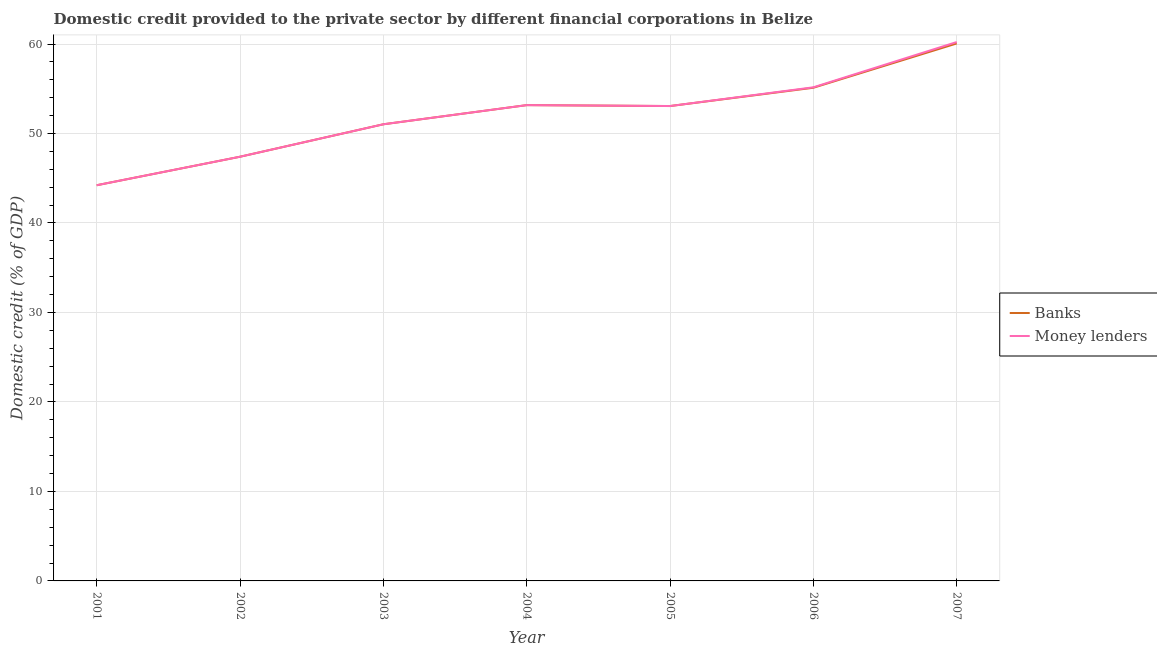How many different coloured lines are there?
Offer a terse response. 2. Does the line corresponding to domestic credit provided by banks intersect with the line corresponding to domestic credit provided by money lenders?
Your answer should be compact. Yes. Is the number of lines equal to the number of legend labels?
Provide a succinct answer. Yes. What is the domestic credit provided by banks in 2001?
Offer a very short reply. 44.22. Across all years, what is the maximum domestic credit provided by banks?
Your answer should be compact. 60.06. Across all years, what is the minimum domestic credit provided by banks?
Make the answer very short. 44.22. In which year was the domestic credit provided by banks maximum?
Keep it short and to the point. 2007. What is the total domestic credit provided by banks in the graph?
Your answer should be very brief. 364.07. What is the difference between the domestic credit provided by money lenders in 2002 and that in 2004?
Provide a succinct answer. -5.77. What is the difference between the domestic credit provided by banks in 2004 and the domestic credit provided by money lenders in 2007?
Provide a succinct answer. -7.05. What is the average domestic credit provided by banks per year?
Your answer should be very brief. 52.01. What is the ratio of the domestic credit provided by banks in 2001 to that in 2005?
Your answer should be compact. 0.83. What is the difference between the highest and the second highest domestic credit provided by banks?
Your answer should be very brief. 4.95. What is the difference between the highest and the lowest domestic credit provided by money lenders?
Provide a short and direct response. 16. In how many years, is the domestic credit provided by money lenders greater than the average domestic credit provided by money lenders taken over all years?
Offer a terse response. 4. Is the domestic credit provided by money lenders strictly less than the domestic credit provided by banks over the years?
Your answer should be very brief. No. How many years are there in the graph?
Your answer should be compact. 7. Are the values on the major ticks of Y-axis written in scientific E-notation?
Offer a terse response. No. Where does the legend appear in the graph?
Give a very brief answer. Center right. How are the legend labels stacked?
Keep it short and to the point. Vertical. What is the title of the graph?
Give a very brief answer. Domestic credit provided to the private sector by different financial corporations in Belize. What is the label or title of the Y-axis?
Your answer should be compact. Domestic credit (% of GDP). What is the Domestic credit (% of GDP) in Banks in 2001?
Keep it short and to the point. 44.22. What is the Domestic credit (% of GDP) of Money lenders in 2001?
Your answer should be very brief. 44.22. What is the Domestic credit (% of GDP) of Banks in 2002?
Offer a terse response. 47.4. What is the Domestic credit (% of GDP) of Money lenders in 2002?
Provide a succinct answer. 47.4. What is the Domestic credit (% of GDP) in Banks in 2003?
Offer a very short reply. 51.03. What is the Domestic credit (% of GDP) in Money lenders in 2003?
Your response must be concise. 51.03. What is the Domestic credit (% of GDP) of Banks in 2004?
Offer a very short reply. 53.17. What is the Domestic credit (% of GDP) of Money lenders in 2004?
Your answer should be compact. 53.17. What is the Domestic credit (% of GDP) in Banks in 2005?
Make the answer very short. 53.07. What is the Domestic credit (% of GDP) in Money lenders in 2005?
Give a very brief answer. 53.07. What is the Domestic credit (% of GDP) of Banks in 2006?
Offer a terse response. 55.11. What is the Domestic credit (% of GDP) of Money lenders in 2006?
Provide a short and direct response. 55.16. What is the Domestic credit (% of GDP) of Banks in 2007?
Your answer should be compact. 60.06. What is the Domestic credit (% of GDP) in Money lenders in 2007?
Offer a terse response. 60.22. Across all years, what is the maximum Domestic credit (% of GDP) in Banks?
Provide a succinct answer. 60.06. Across all years, what is the maximum Domestic credit (% of GDP) in Money lenders?
Offer a terse response. 60.22. Across all years, what is the minimum Domestic credit (% of GDP) of Banks?
Ensure brevity in your answer.  44.22. Across all years, what is the minimum Domestic credit (% of GDP) of Money lenders?
Keep it short and to the point. 44.22. What is the total Domestic credit (% of GDP) of Banks in the graph?
Offer a terse response. 364.07. What is the total Domestic credit (% of GDP) in Money lenders in the graph?
Your answer should be compact. 364.27. What is the difference between the Domestic credit (% of GDP) of Banks in 2001 and that in 2002?
Offer a terse response. -3.19. What is the difference between the Domestic credit (% of GDP) of Money lenders in 2001 and that in 2002?
Your answer should be compact. -3.19. What is the difference between the Domestic credit (% of GDP) of Banks in 2001 and that in 2003?
Offer a terse response. -6.81. What is the difference between the Domestic credit (% of GDP) in Money lenders in 2001 and that in 2003?
Your answer should be compact. -6.81. What is the difference between the Domestic credit (% of GDP) in Banks in 2001 and that in 2004?
Your answer should be compact. -8.95. What is the difference between the Domestic credit (% of GDP) in Money lenders in 2001 and that in 2004?
Your response must be concise. -8.95. What is the difference between the Domestic credit (% of GDP) of Banks in 2001 and that in 2005?
Offer a terse response. -8.85. What is the difference between the Domestic credit (% of GDP) in Money lenders in 2001 and that in 2005?
Ensure brevity in your answer.  -8.85. What is the difference between the Domestic credit (% of GDP) of Banks in 2001 and that in 2006?
Provide a short and direct response. -10.9. What is the difference between the Domestic credit (% of GDP) in Money lenders in 2001 and that in 2006?
Provide a short and direct response. -10.94. What is the difference between the Domestic credit (% of GDP) of Banks in 2001 and that in 2007?
Provide a succinct answer. -15.85. What is the difference between the Domestic credit (% of GDP) of Money lenders in 2001 and that in 2007?
Offer a very short reply. -16. What is the difference between the Domestic credit (% of GDP) of Banks in 2002 and that in 2003?
Provide a short and direct response. -3.63. What is the difference between the Domestic credit (% of GDP) in Money lenders in 2002 and that in 2003?
Provide a short and direct response. -3.63. What is the difference between the Domestic credit (% of GDP) in Banks in 2002 and that in 2004?
Your response must be concise. -5.77. What is the difference between the Domestic credit (% of GDP) in Money lenders in 2002 and that in 2004?
Your answer should be compact. -5.77. What is the difference between the Domestic credit (% of GDP) of Banks in 2002 and that in 2005?
Offer a terse response. -5.66. What is the difference between the Domestic credit (% of GDP) of Money lenders in 2002 and that in 2005?
Provide a short and direct response. -5.66. What is the difference between the Domestic credit (% of GDP) in Banks in 2002 and that in 2006?
Your answer should be compact. -7.71. What is the difference between the Domestic credit (% of GDP) of Money lenders in 2002 and that in 2006?
Make the answer very short. -7.76. What is the difference between the Domestic credit (% of GDP) of Banks in 2002 and that in 2007?
Your response must be concise. -12.66. What is the difference between the Domestic credit (% of GDP) in Money lenders in 2002 and that in 2007?
Your answer should be very brief. -12.82. What is the difference between the Domestic credit (% of GDP) of Banks in 2003 and that in 2004?
Provide a short and direct response. -2.14. What is the difference between the Domestic credit (% of GDP) of Money lenders in 2003 and that in 2004?
Provide a succinct answer. -2.14. What is the difference between the Domestic credit (% of GDP) of Banks in 2003 and that in 2005?
Provide a short and direct response. -2.04. What is the difference between the Domestic credit (% of GDP) in Money lenders in 2003 and that in 2005?
Your answer should be very brief. -2.04. What is the difference between the Domestic credit (% of GDP) in Banks in 2003 and that in 2006?
Ensure brevity in your answer.  -4.08. What is the difference between the Domestic credit (% of GDP) of Money lenders in 2003 and that in 2006?
Your answer should be compact. -4.13. What is the difference between the Domestic credit (% of GDP) of Banks in 2003 and that in 2007?
Provide a succinct answer. -9.03. What is the difference between the Domestic credit (% of GDP) of Money lenders in 2003 and that in 2007?
Keep it short and to the point. -9.19. What is the difference between the Domestic credit (% of GDP) in Banks in 2004 and that in 2005?
Your answer should be compact. 0.1. What is the difference between the Domestic credit (% of GDP) of Money lenders in 2004 and that in 2005?
Your answer should be compact. 0.1. What is the difference between the Domestic credit (% of GDP) of Banks in 2004 and that in 2006?
Provide a succinct answer. -1.94. What is the difference between the Domestic credit (% of GDP) of Money lenders in 2004 and that in 2006?
Provide a short and direct response. -1.99. What is the difference between the Domestic credit (% of GDP) in Banks in 2004 and that in 2007?
Ensure brevity in your answer.  -6.89. What is the difference between the Domestic credit (% of GDP) in Money lenders in 2004 and that in 2007?
Keep it short and to the point. -7.05. What is the difference between the Domestic credit (% of GDP) in Banks in 2005 and that in 2006?
Your response must be concise. -2.04. What is the difference between the Domestic credit (% of GDP) in Money lenders in 2005 and that in 2006?
Give a very brief answer. -2.09. What is the difference between the Domestic credit (% of GDP) of Banks in 2005 and that in 2007?
Offer a terse response. -6.99. What is the difference between the Domestic credit (% of GDP) in Money lenders in 2005 and that in 2007?
Offer a very short reply. -7.15. What is the difference between the Domestic credit (% of GDP) in Banks in 2006 and that in 2007?
Your answer should be compact. -4.95. What is the difference between the Domestic credit (% of GDP) of Money lenders in 2006 and that in 2007?
Keep it short and to the point. -5.06. What is the difference between the Domestic credit (% of GDP) of Banks in 2001 and the Domestic credit (% of GDP) of Money lenders in 2002?
Offer a terse response. -3.19. What is the difference between the Domestic credit (% of GDP) in Banks in 2001 and the Domestic credit (% of GDP) in Money lenders in 2003?
Make the answer very short. -6.81. What is the difference between the Domestic credit (% of GDP) of Banks in 2001 and the Domestic credit (% of GDP) of Money lenders in 2004?
Your answer should be very brief. -8.95. What is the difference between the Domestic credit (% of GDP) in Banks in 2001 and the Domestic credit (% of GDP) in Money lenders in 2005?
Offer a very short reply. -8.85. What is the difference between the Domestic credit (% of GDP) in Banks in 2001 and the Domestic credit (% of GDP) in Money lenders in 2006?
Your answer should be very brief. -10.94. What is the difference between the Domestic credit (% of GDP) of Banks in 2001 and the Domestic credit (% of GDP) of Money lenders in 2007?
Make the answer very short. -16. What is the difference between the Domestic credit (% of GDP) of Banks in 2002 and the Domestic credit (% of GDP) of Money lenders in 2003?
Ensure brevity in your answer.  -3.63. What is the difference between the Domestic credit (% of GDP) of Banks in 2002 and the Domestic credit (% of GDP) of Money lenders in 2004?
Make the answer very short. -5.77. What is the difference between the Domestic credit (% of GDP) of Banks in 2002 and the Domestic credit (% of GDP) of Money lenders in 2005?
Provide a short and direct response. -5.66. What is the difference between the Domestic credit (% of GDP) in Banks in 2002 and the Domestic credit (% of GDP) in Money lenders in 2006?
Ensure brevity in your answer.  -7.76. What is the difference between the Domestic credit (% of GDP) in Banks in 2002 and the Domestic credit (% of GDP) in Money lenders in 2007?
Give a very brief answer. -12.82. What is the difference between the Domestic credit (% of GDP) of Banks in 2003 and the Domestic credit (% of GDP) of Money lenders in 2004?
Offer a terse response. -2.14. What is the difference between the Domestic credit (% of GDP) in Banks in 2003 and the Domestic credit (% of GDP) in Money lenders in 2005?
Keep it short and to the point. -2.04. What is the difference between the Domestic credit (% of GDP) in Banks in 2003 and the Domestic credit (% of GDP) in Money lenders in 2006?
Make the answer very short. -4.13. What is the difference between the Domestic credit (% of GDP) in Banks in 2003 and the Domestic credit (% of GDP) in Money lenders in 2007?
Make the answer very short. -9.19. What is the difference between the Domestic credit (% of GDP) of Banks in 2004 and the Domestic credit (% of GDP) of Money lenders in 2005?
Offer a very short reply. 0.1. What is the difference between the Domestic credit (% of GDP) of Banks in 2004 and the Domestic credit (% of GDP) of Money lenders in 2006?
Give a very brief answer. -1.99. What is the difference between the Domestic credit (% of GDP) in Banks in 2004 and the Domestic credit (% of GDP) in Money lenders in 2007?
Provide a short and direct response. -7.05. What is the difference between the Domestic credit (% of GDP) in Banks in 2005 and the Domestic credit (% of GDP) in Money lenders in 2006?
Offer a very short reply. -2.09. What is the difference between the Domestic credit (% of GDP) in Banks in 2005 and the Domestic credit (% of GDP) in Money lenders in 2007?
Your answer should be very brief. -7.15. What is the difference between the Domestic credit (% of GDP) in Banks in 2006 and the Domestic credit (% of GDP) in Money lenders in 2007?
Keep it short and to the point. -5.11. What is the average Domestic credit (% of GDP) in Banks per year?
Provide a short and direct response. 52.01. What is the average Domestic credit (% of GDP) in Money lenders per year?
Offer a very short reply. 52.04. In the year 2001, what is the difference between the Domestic credit (% of GDP) in Banks and Domestic credit (% of GDP) in Money lenders?
Ensure brevity in your answer.  0. In the year 2002, what is the difference between the Domestic credit (% of GDP) of Banks and Domestic credit (% of GDP) of Money lenders?
Offer a very short reply. 0. In the year 2003, what is the difference between the Domestic credit (% of GDP) in Banks and Domestic credit (% of GDP) in Money lenders?
Ensure brevity in your answer.  0. In the year 2005, what is the difference between the Domestic credit (% of GDP) of Banks and Domestic credit (% of GDP) of Money lenders?
Provide a short and direct response. 0. In the year 2006, what is the difference between the Domestic credit (% of GDP) of Banks and Domestic credit (% of GDP) of Money lenders?
Ensure brevity in your answer.  -0.05. In the year 2007, what is the difference between the Domestic credit (% of GDP) in Banks and Domestic credit (% of GDP) in Money lenders?
Keep it short and to the point. -0.16. What is the ratio of the Domestic credit (% of GDP) of Banks in 2001 to that in 2002?
Keep it short and to the point. 0.93. What is the ratio of the Domestic credit (% of GDP) in Money lenders in 2001 to that in 2002?
Give a very brief answer. 0.93. What is the ratio of the Domestic credit (% of GDP) of Banks in 2001 to that in 2003?
Your response must be concise. 0.87. What is the ratio of the Domestic credit (% of GDP) in Money lenders in 2001 to that in 2003?
Offer a terse response. 0.87. What is the ratio of the Domestic credit (% of GDP) in Banks in 2001 to that in 2004?
Keep it short and to the point. 0.83. What is the ratio of the Domestic credit (% of GDP) of Money lenders in 2001 to that in 2004?
Give a very brief answer. 0.83. What is the ratio of the Domestic credit (% of GDP) in Banks in 2001 to that in 2005?
Your answer should be very brief. 0.83. What is the ratio of the Domestic credit (% of GDP) in Money lenders in 2001 to that in 2005?
Provide a succinct answer. 0.83. What is the ratio of the Domestic credit (% of GDP) in Banks in 2001 to that in 2006?
Provide a succinct answer. 0.8. What is the ratio of the Domestic credit (% of GDP) in Money lenders in 2001 to that in 2006?
Offer a very short reply. 0.8. What is the ratio of the Domestic credit (% of GDP) in Banks in 2001 to that in 2007?
Provide a succinct answer. 0.74. What is the ratio of the Domestic credit (% of GDP) in Money lenders in 2001 to that in 2007?
Provide a succinct answer. 0.73. What is the ratio of the Domestic credit (% of GDP) of Banks in 2002 to that in 2003?
Provide a succinct answer. 0.93. What is the ratio of the Domestic credit (% of GDP) in Money lenders in 2002 to that in 2003?
Make the answer very short. 0.93. What is the ratio of the Domestic credit (% of GDP) of Banks in 2002 to that in 2004?
Keep it short and to the point. 0.89. What is the ratio of the Domestic credit (% of GDP) in Money lenders in 2002 to that in 2004?
Offer a terse response. 0.89. What is the ratio of the Domestic credit (% of GDP) of Banks in 2002 to that in 2005?
Provide a succinct answer. 0.89. What is the ratio of the Domestic credit (% of GDP) of Money lenders in 2002 to that in 2005?
Your answer should be very brief. 0.89. What is the ratio of the Domestic credit (% of GDP) in Banks in 2002 to that in 2006?
Provide a succinct answer. 0.86. What is the ratio of the Domestic credit (% of GDP) of Money lenders in 2002 to that in 2006?
Keep it short and to the point. 0.86. What is the ratio of the Domestic credit (% of GDP) in Banks in 2002 to that in 2007?
Give a very brief answer. 0.79. What is the ratio of the Domestic credit (% of GDP) of Money lenders in 2002 to that in 2007?
Give a very brief answer. 0.79. What is the ratio of the Domestic credit (% of GDP) of Banks in 2003 to that in 2004?
Offer a very short reply. 0.96. What is the ratio of the Domestic credit (% of GDP) of Money lenders in 2003 to that in 2004?
Keep it short and to the point. 0.96. What is the ratio of the Domestic credit (% of GDP) of Banks in 2003 to that in 2005?
Make the answer very short. 0.96. What is the ratio of the Domestic credit (% of GDP) in Money lenders in 2003 to that in 2005?
Offer a very short reply. 0.96. What is the ratio of the Domestic credit (% of GDP) of Banks in 2003 to that in 2006?
Provide a short and direct response. 0.93. What is the ratio of the Domestic credit (% of GDP) of Money lenders in 2003 to that in 2006?
Your answer should be very brief. 0.93. What is the ratio of the Domestic credit (% of GDP) of Banks in 2003 to that in 2007?
Your answer should be very brief. 0.85. What is the ratio of the Domestic credit (% of GDP) of Money lenders in 2003 to that in 2007?
Ensure brevity in your answer.  0.85. What is the ratio of the Domestic credit (% of GDP) of Money lenders in 2004 to that in 2005?
Keep it short and to the point. 1. What is the ratio of the Domestic credit (% of GDP) of Banks in 2004 to that in 2006?
Provide a short and direct response. 0.96. What is the ratio of the Domestic credit (% of GDP) in Money lenders in 2004 to that in 2006?
Keep it short and to the point. 0.96. What is the ratio of the Domestic credit (% of GDP) in Banks in 2004 to that in 2007?
Ensure brevity in your answer.  0.89. What is the ratio of the Domestic credit (% of GDP) of Money lenders in 2004 to that in 2007?
Provide a short and direct response. 0.88. What is the ratio of the Domestic credit (% of GDP) in Banks in 2005 to that in 2006?
Make the answer very short. 0.96. What is the ratio of the Domestic credit (% of GDP) of Banks in 2005 to that in 2007?
Your answer should be compact. 0.88. What is the ratio of the Domestic credit (% of GDP) in Money lenders in 2005 to that in 2007?
Make the answer very short. 0.88. What is the ratio of the Domestic credit (% of GDP) in Banks in 2006 to that in 2007?
Make the answer very short. 0.92. What is the ratio of the Domestic credit (% of GDP) of Money lenders in 2006 to that in 2007?
Keep it short and to the point. 0.92. What is the difference between the highest and the second highest Domestic credit (% of GDP) in Banks?
Ensure brevity in your answer.  4.95. What is the difference between the highest and the second highest Domestic credit (% of GDP) of Money lenders?
Your answer should be very brief. 5.06. What is the difference between the highest and the lowest Domestic credit (% of GDP) in Banks?
Keep it short and to the point. 15.85. What is the difference between the highest and the lowest Domestic credit (% of GDP) of Money lenders?
Your answer should be compact. 16. 